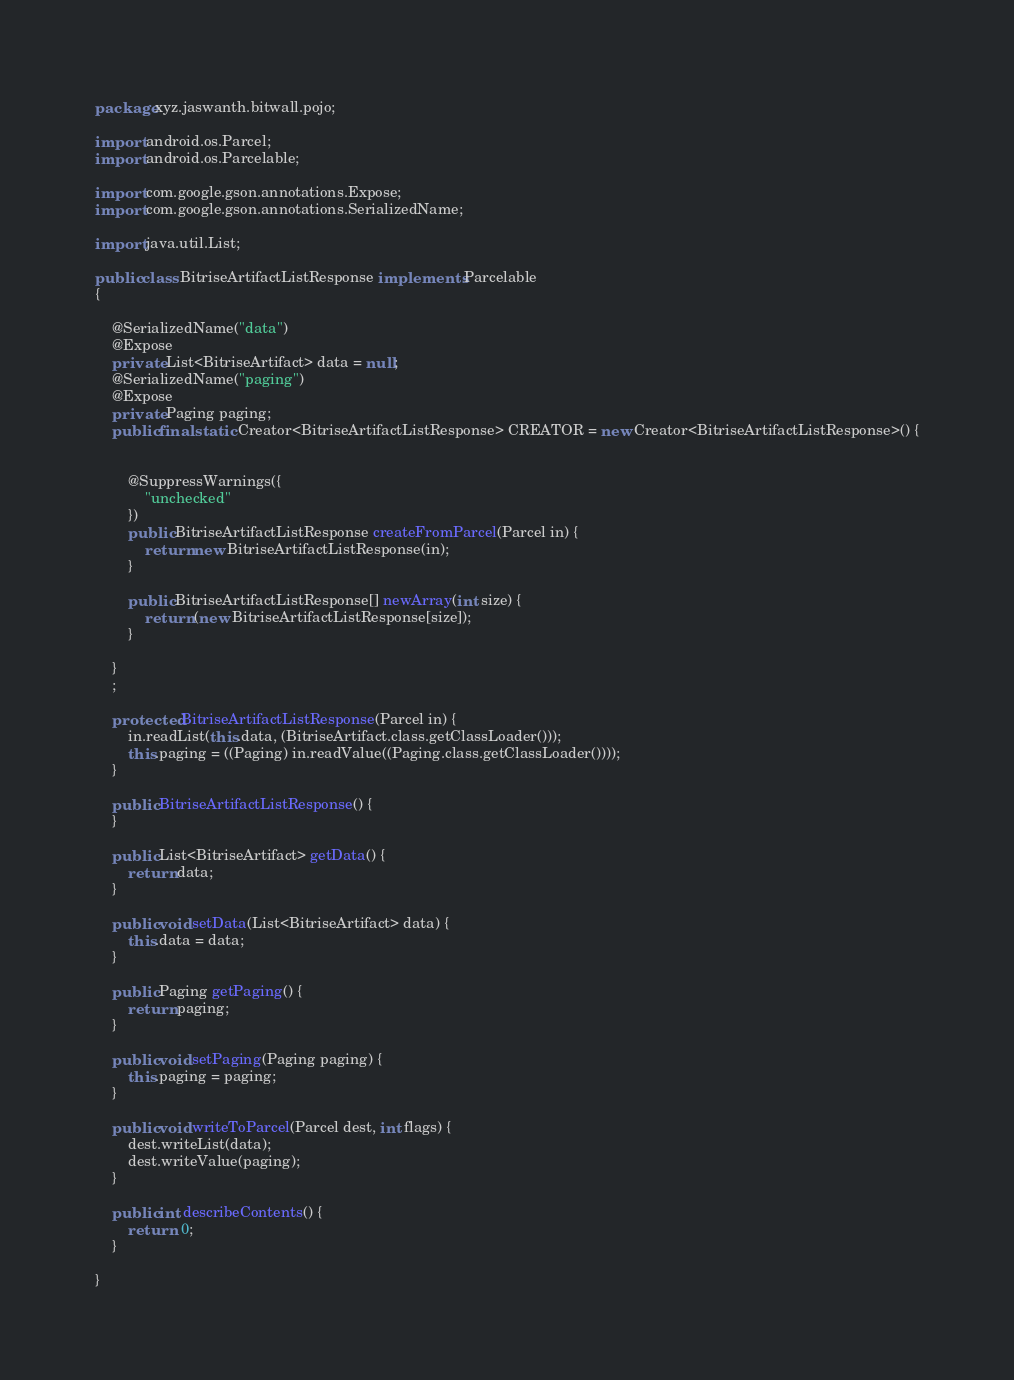Convert code to text. <code><loc_0><loc_0><loc_500><loc_500><_Java_>
package xyz.jaswanth.bitwall.pojo;

import android.os.Parcel;
import android.os.Parcelable;

import com.google.gson.annotations.Expose;
import com.google.gson.annotations.SerializedName;

import java.util.List;

public class BitriseArtifactListResponse implements Parcelable
{

    @SerializedName("data")
    @Expose
    private List<BitriseArtifact> data = null;
    @SerializedName("paging")
    @Expose
    private Paging paging;
    public final static Creator<BitriseArtifactListResponse> CREATOR = new Creator<BitriseArtifactListResponse>() {


        @SuppressWarnings({
            "unchecked"
        })
        public BitriseArtifactListResponse createFromParcel(Parcel in) {
            return new BitriseArtifactListResponse(in);
        }

        public BitriseArtifactListResponse[] newArray(int size) {
            return (new BitriseArtifactListResponse[size]);
        }

    }
    ;

    protected BitriseArtifactListResponse(Parcel in) {
        in.readList(this.data, (BitriseArtifact.class.getClassLoader()));
        this.paging = ((Paging) in.readValue((Paging.class.getClassLoader())));
    }

    public BitriseArtifactListResponse() {
    }

    public List<BitriseArtifact> getData() {
        return data;
    }

    public void setData(List<BitriseArtifact> data) {
        this.data = data;
    }

    public Paging getPaging() {
        return paging;
    }

    public void setPaging(Paging paging) {
        this.paging = paging;
    }

    public void writeToParcel(Parcel dest, int flags) {
        dest.writeList(data);
        dest.writeValue(paging);
    }

    public int describeContents() {
        return  0;
    }

}
</code> 